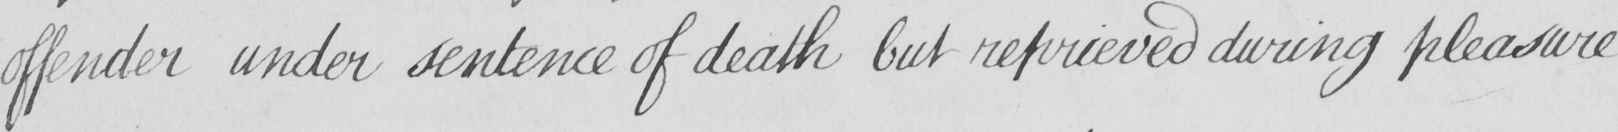What does this handwritten line say? offender under sentence of death but reprieved during pleasure 